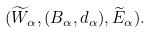Convert formula to latex. <formula><loc_0><loc_0><loc_500><loc_500>( \widetilde { W } _ { \alpha } , ( B _ { \alpha } , d _ { \alpha } ) , \widetilde { E } _ { \alpha } ) .</formula> 